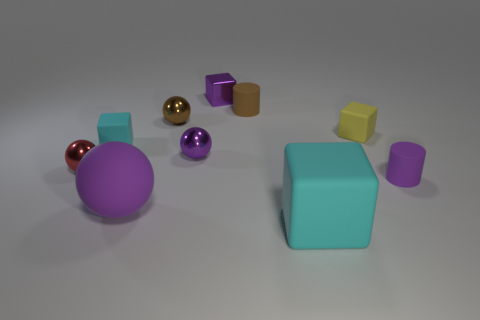Does the tiny thing behind the brown rubber object have the same shape as the tiny object that is on the right side of the tiny yellow block?
Your answer should be compact. No. Are any tiny red balls visible?
Provide a succinct answer. Yes. There is a large rubber object that is the same shape as the tiny brown metallic object; what is its color?
Your answer should be compact. Purple. There is a metal cube that is the same size as the red metal thing; what color is it?
Make the answer very short. Purple. Do the red sphere and the small yellow object have the same material?
Make the answer very short. No. What number of matte spheres are the same color as the metallic cube?
Keep it short and to the point. 1. Does the big rubber cube have the same color as the small metallic cube?
Provide a short and direct response. No. What is the cyan thing behind the large purple object made of?
Provide a succinct answer. Rubber. What number of tiny objects are purple metal things or cyan matte things?
Keep it short and to the point. 3. There is a small object that is the same color as the big cube; what is it made of?
Offer a terse response. Rubber. 